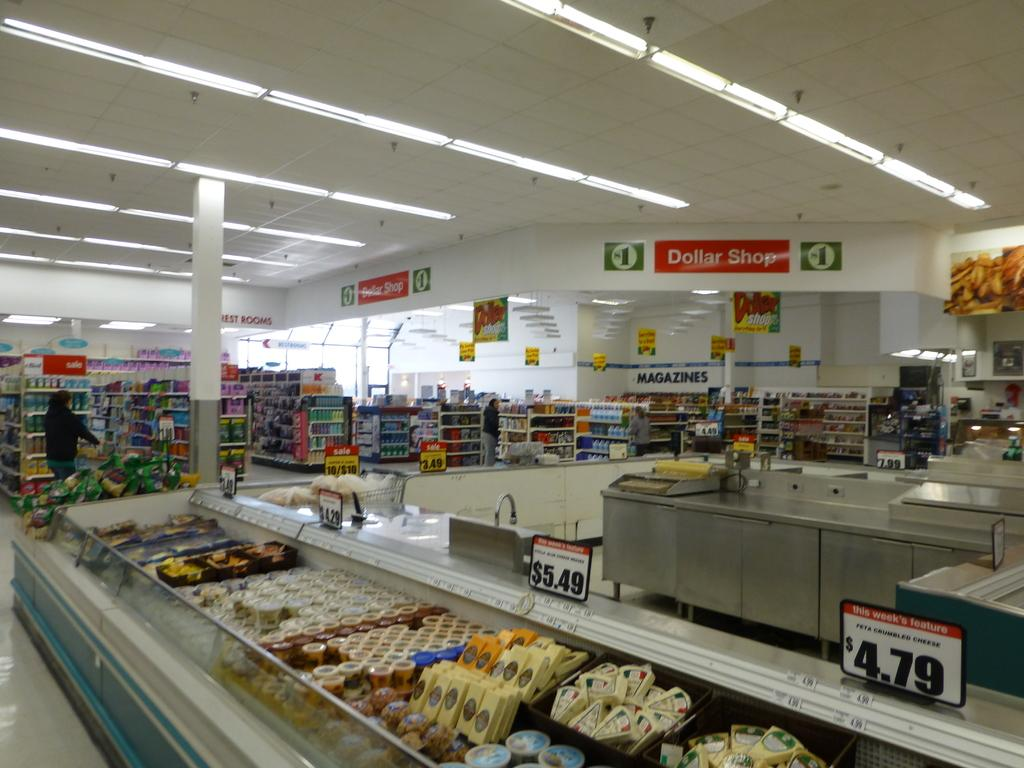<image>
Relay a brief, clear account of the picture shown. the inside of a store that says 'dollar shop' at the top on a sign 